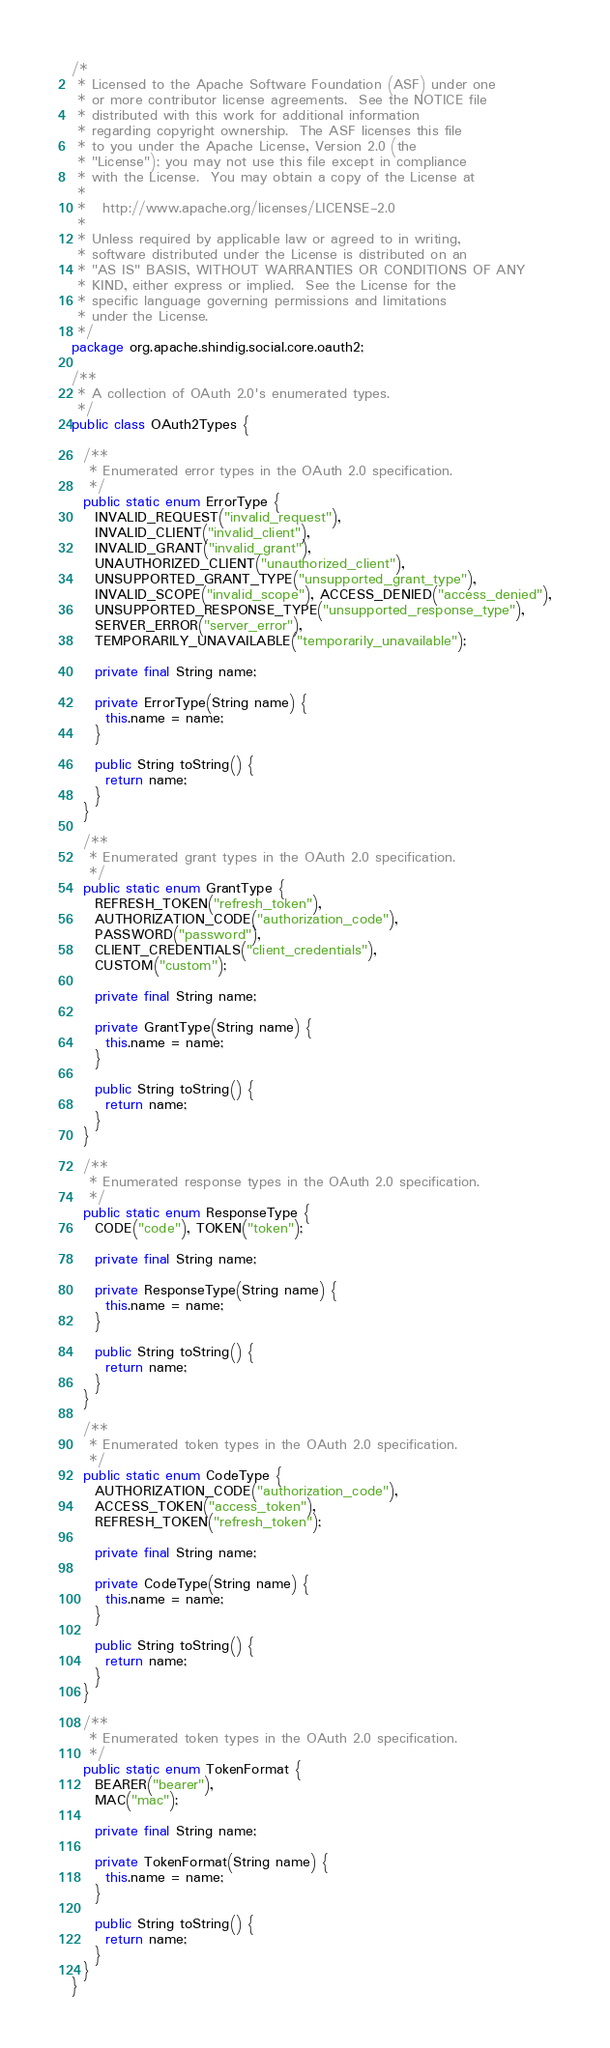Convert code to text. <code><loc_0><loc_0><loc_500><loc_500><_Java_>/*
 * Licensed to the Apache Software Foundation (ASF) under one
 * or more contributor license agreements.  See the NOTICE file
 * distributed with this work for additional information
 * regarding copyright ownership.  The ASF licenses this file
 * to you under the Apache License, Version 2.0 (the
 * "License"); you may not use this file except in compliance
 * with the License.  You may obtain a copy of the License at
 *
 *   http://www.apache.org/licenses/LICENSE-2.0
 *
 * Unless required by applicable law or agreed to in writing,
 * software distributed under the License is distributed on an
 * "AS IS" BASIS, WITHOUT WARRANTIES OR CONDITIONS OF ANY
 * KIND, either express or implied.  See the License for the
 * specific language governing permissions and limitations
 * under the License.
 */
package org.apache.shindig.social.core.oauth2;

/**
 * A collection of OAuth 2.0's enumerated types.
 */
public class OAuth2Types {

  /**
   * Enumerated error types in the OAuth 2.0 specification.
   */
  public static enum ErrorType {
    INVALID_REQUEST("invalid_request"),
    INVALID_CLIENT("invalid_client"),
    INVALID_GRANT("invalid_grant"),
    UNAUTHORIZED_CLIENT("unauthorized_client"),
    UNSUPPORTED_GRANT_TYPE("unsupported_grant_type"),
    INVALID_SCOPE("invalid_scope"), ACCESS_DENIED("access_denied"),
    UNSUPPORTED_RESPONSE_TYPE("unsupported_response_type"),
    SERVER_ERROR("server_error"),
    TEMPORARILY_UNAVAILABLE("temporarily_unavailable");

    private final String name;

    private ErrorType(String name) {
      this.name = name;
    }

    public String toString() {
      return name;
    }
  }

  /**
   * Enumerated grant types in the OAuth 2.0 specification.
   */
  public static enum GrantType {
    REFRESH_TOKEN("refresh_token"),
    AUTHORIZATION_CODE("authorization_code"),
    PASSWORD("password"),
    CLIENT_CREDENTIALS("client_credentials"),
    CUSTOM("custom");

    private final String name;

    private GrantType(String name) {
      this.name = name;
    }

    public String toString() {
      return name;
    }
  }

  /**
   * Enumerated response types in the OAuth 2.0 specification.
   */
  public static enum ResponseType {
    CODE("code"), TOKEN("token");

    private final String name;

    private ResponseType(String name) {
      this.name = name;
    }

    public String toString() {
      return name;
    }
  }

  /**
   * Enumerated token types in the OAuth 2.0 specification.
   */
  public static enum CodeType {
    AUTHORIZATION_CODE("authorization_code"),
    ACCESS_TOKEN("access_token"),
    REFRESH_TOKEN("refresh_token");

    private final String name;

    private CodeType(String name) {
      this.name = name;
    }

    public String toString() {
      return name;
    }
  }

  /**
   * Enumerated token types in the OAuth 2.0 specification.
   */
  public static enum TokenFormat {
    BEARER("bearer"),
    MAC("mac");

    private final String name;

    private TokenFormat(String name) {
      this.name = name;
    }

    public String toString() {
      return name;
    }
  }
}
</code> 